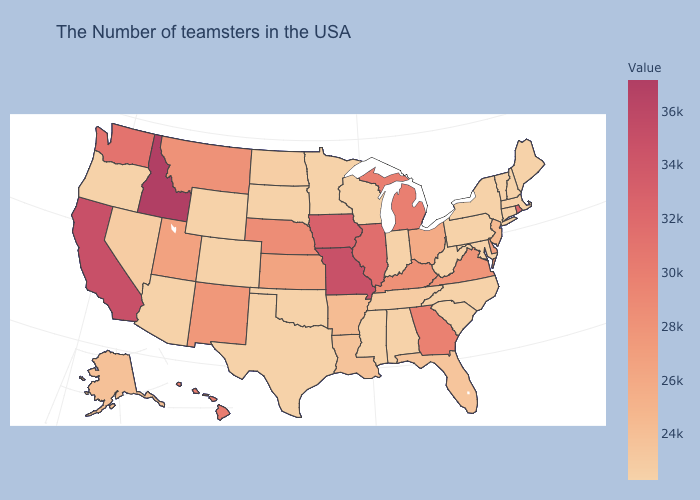Which states have the lowest value in the USA?
Write a very short answer. Maine, Massachusetts, New Hampshire, Vermont, Connecticut, New York, Maryland, Pennsylvania, North Carolina, South Carolina, West Virginia, Indiana, Alabama, Wisconsin, Mississippi, Minnesota, Oklahoma, Texas, South Dakota, Wyoming, Colorado, Arizona, Oregon. Which states have the lowest value in the MidWest?
Quick response, please. Indiana, Wisconsin, Minnesota, South Dakota. Which states have the lowest value in the USA?
Answer briefly. Maine, Massachusetts, New Hampshire, Vermont, Connecticut, New York, Maryland, Pennsylvania, North Carolina, South Carolina, West Virginia, Indiana, Alabama, Wisconsin, Mississippi, Minnesota, Oklahoma, Texas, South Dakota, Wyoming, Colorado, Arizona, Oregon. Which states have the highest value in the USA?
Concise answer only. Idaho. Which states have the lowest value in the USA?
Write a very short answer. Maine, Massachusetts, New Hampshire, Vermont, Connecticut, New York, Maryland, Pennsylvania, North Carolina, South Carolina, West Virginia, Indiana, Alabama, Wisconsin, Mississippi, Minnesota, Oklahoma, Texas, South Dakota, Wyoming, Colorado, Arizona, Oregon. Among the states that border West Virginia , which have the lowest value?
Be succinct. Maryland, Pennsylvania. 